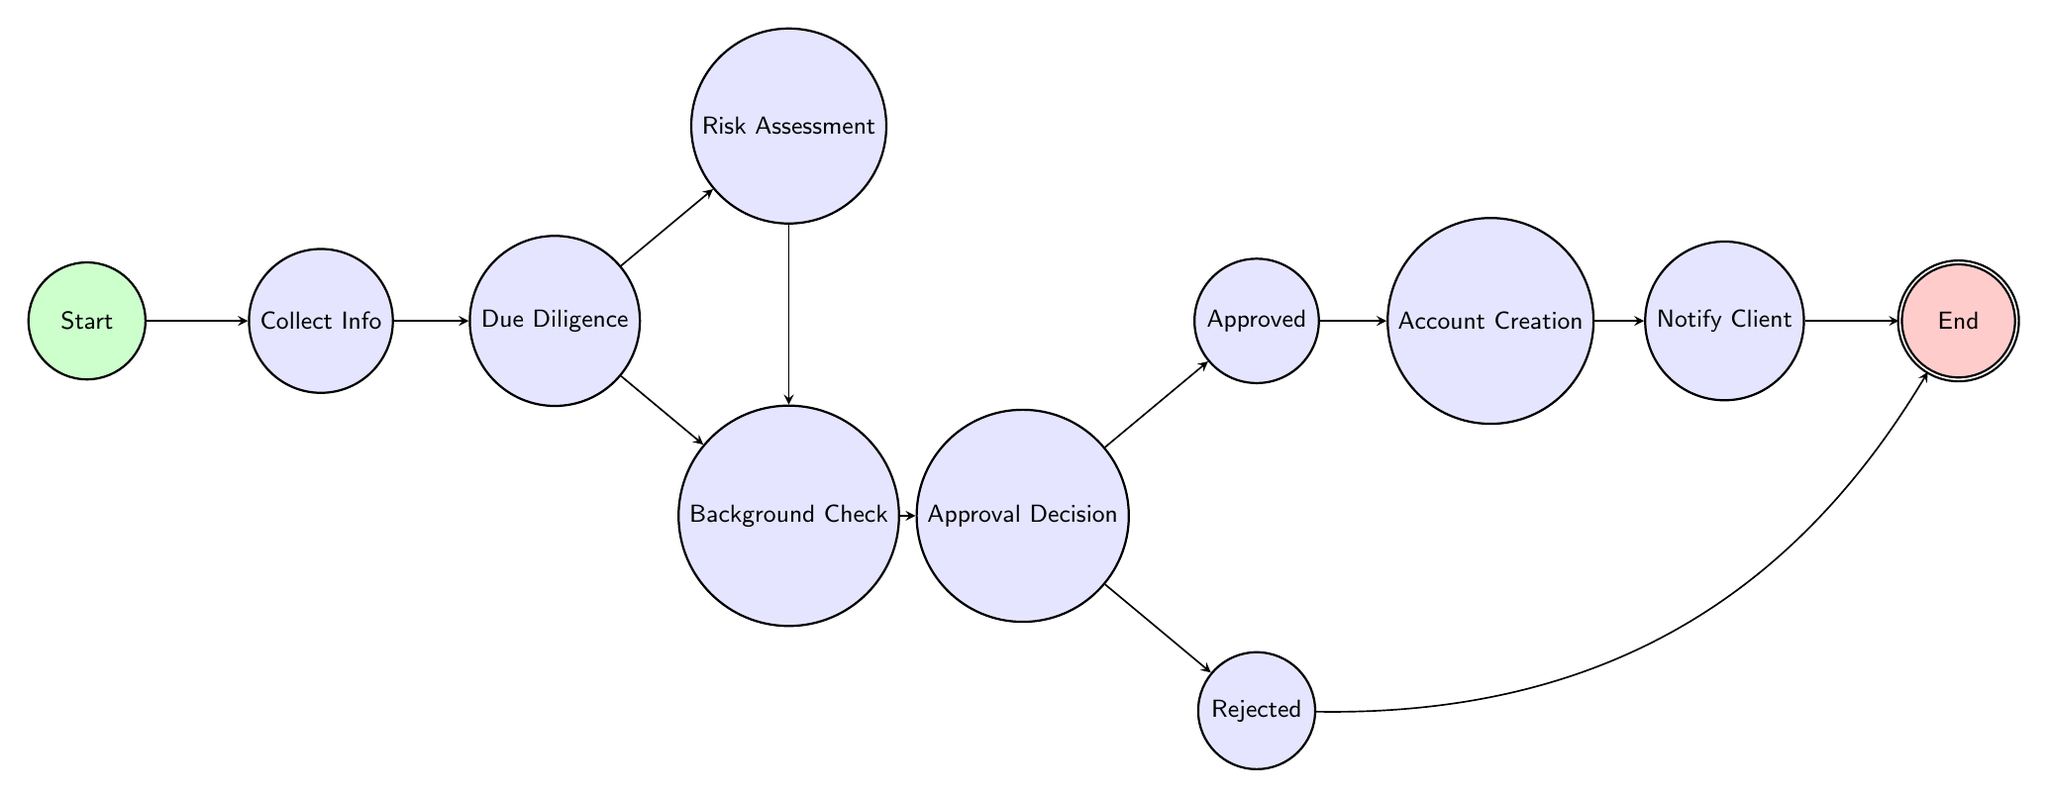What is the first state in the onboarding process? The diagram begins at the node labeled "Start," which is the first state in the onboarding process.
Answer: Start How many states are there in the onboarding process? By counting the nodes in the diagram, there are a total of eleven states, including the starting and ending states.
Answer: Eleven What state follows "Perform Due Diligence"? After "Perform Due Diligence," the state transitions to either "Risk Assessment" or "Background Check," indicating that both are subsequent states.
Answer: Risk Assessment, Background Check What describes the "Approval Decision" state? The "Approval Decision" state indicates making a choice regarding the client's onboarding, determining whether to approve or reject the application.
Answer: Decide whether to approve or reject Which state has transitions to both "Approved" and "Rejected"? The "Approval Decision" state is the one that has transitions leading to both "Approved" and "Rejected," showcasing a decision point in the process.
Answer: Approval Decision If a client is approved, what state comes next? If a client is approved, the next state in the onboarding process is "Account Creation," which involves setting up an account for the client.
Answer: Account Creation What is the final state after notifying the client? After the "Notify Client" state, the process culminates in the state labeled "End," indicating the completion of the onboarding process.
Answer: End Which state performs KYC and anti-money laundering checks? The state responsible for conducting KYC and anti-money laundering checks is "Perform Due Diligence," which is crucial for the compliance process.
Answer: Perform Due Diligence What action follows the "Account Creation" state? Following "Account Creation," the next action is to "Notify Client," where the client is informed about the success of the onboarding process.
Answer: Notify Client 